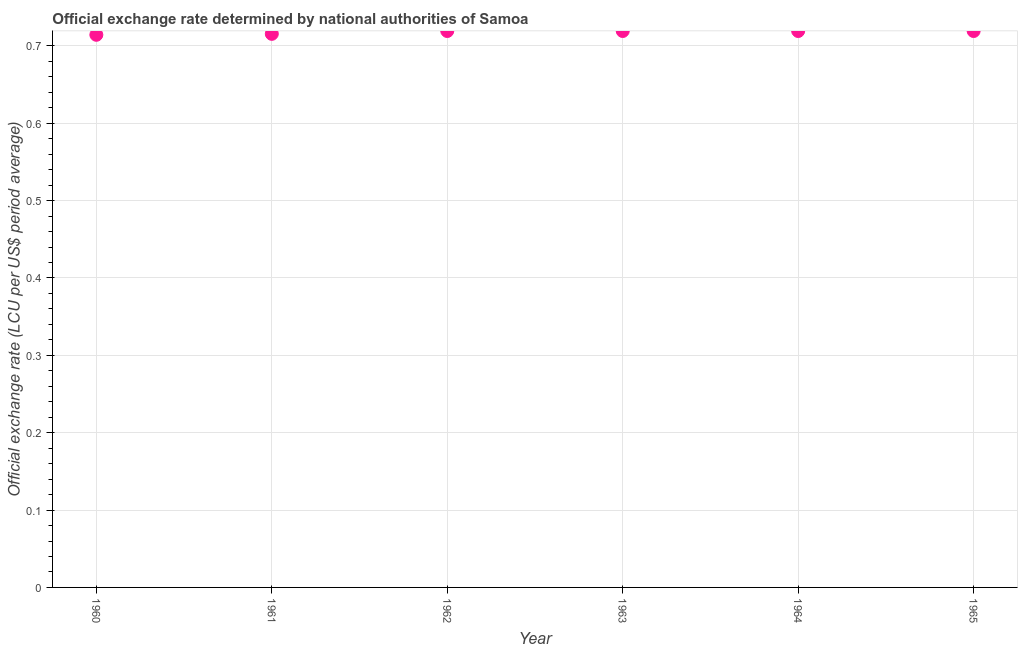What is the official exchange rate in 1965?
Make the answer very short. 0.72. Across all years, what is the maximum official exchange rate?
Make the answer very short. 0.72. Across all years, what is the minimum official exchange rate?
Your answer should be very brief. 0.71. In which year was the official exchange rate maximum?
Provide a succinct answer. 1962. In which year was the official exchange rate minimum?
Provide a short and direct response. 1960. What is the sum of the official exchange rate?
Provide a succinct answer. 4.31. What is the difference between the official exchange rate in 1961 and 1965?
Give a very brief answer. -0. What is the average official exchange rate per year?
Offer a terse response. 0.72. What is the median official exchange rate?
Provide a short and direct response. 0.72. Do a majority of the years between 1964 and 1960 (inclusive) have official exchange rate greater than 0.36000000000000004 ?
Ensure brevity in your answer.  Yes. What is the ratio of the official exchange rate in 1961 to that in 1962?
Ensure brevity in your answer.  0.99. Is the official exchange rate in 1962 less than that in 1964?
Make the answer very short. No. Is the difference between the official exchange rate in 1963 and 1964 greater than the difference between any two years?
Give a very brief answer. No. What is the difference between the highest and the second highest official exchange rate?
Provide a short and direct response. 0. Is the sum of the official exchange rate in 1963 and 1965 greater than the maximum official exchange rate across all years?
Offer a very short reply. Yes. What is the difference between the highest and the lowest official exchange rate?
Make the answer very short. 0. Does the official exchange rate monotonically increase over the years?
Your response must be concise. No. How many dotlines are there?
Offer a very short reply. 1. How many years are there in the graph?
Your answer should be very brief. 6. Are the values on the major ticks of Y-axis written in scientific E-notation?
Your answer should be very brief. No. Does the graph contain grids?
Make the answer very short. Yes. What is the title of the graph?
Ensure brevity in your answer.  Official exchange rate determined by national authorities of Samoa. What is the label or title of the Y-axis?
Provide a short and direct response. Official exchange rate (LCU per US$ period average). What is the Official exchange rate (LCU per US$ period average) in 1960?
Offer a very short reply. 0.71. What is the Official exchange rate (LCU per US$ period average) in 1961?
Keep it short and to the point. 0.72. What is the Official exchange rate (LCU per US$ period average) in 1962?
Offer a very short reply. 0.72. What is the Official exchange rate (LCU per US$ period average) in 1963?
Your response must be concise. 0.72. What is the Official exchange rate (LCU per US$ period average) in 1964?
Your answer should be compact. 0.72. What is the Official exchange rate (LCU per US$ period average) in 1965?
Provide a succinct answer. 0.72. What is the difference between the Official exchange rate (LCU per US$ period average) in 1960 and 1961?
Your answer should be very brief. -0. What is the difference between the Official exchange rate (LCU per US$ period average) in 1960 and 1962?
Your answer should be compact. -0. What is the difference between the Official exchange rate (LCU per US$ period average) in 1960 and 1963?
Provide a succinct answer. -0. What is the difference between the Official exchange rate (LCU per US$ period average) in 1960 and 1964?
Offer a terse response. -0. What is the difference between the Official exchange rate (LCU per US$ period average) in 1960 and 1965?
Offer a terse response. -0. What is the difference between the Official exchange rate (LCU per US$ period average) in 1961 and 1962?
Your response must be concise. -0. What is the difference between the Official exchange rate (LCU per US$ period average) in 1961 and 1963?
Your answer should be very brief. -0. What is the difference between the Official exchange rate (LCU per US$ period average) in 1961 and 1964?
Give a very brief answer. -0. What is the difference between the Official exchange rate (LCU per US$ period average) in 1961 and 1965?
Offer a very short reply. -0. What is the difference between the Official exchange rate (LCU per US$ period average) in 1962 and 1963?
Provide a short and direct response. 0. What is the difference between the Official exchange rate (LCU per US$ period average) in 1962 and 1965?
Keep it short and to the point. 0. What is the difference between the Official exchange rate (LCU per US$ period average) in 1963 and 1964?
Offer a terse response. 0. What is the difference between the Official exchange rate (LCU per US$ period average) in 1963 and 1965?
Provide a succinct answer. 0. What is the difference between the Official exchange rate (LCU per US$ period average) in 1964 and 1965?
Your answer should be very brief. 0. What is the ratio of the Official exchange rate (LCU per US$ period average) in 1960 to that in 1962?
Offer a terse response. 0.99. What is the ratio of the Official exchange rate (LCU per US$ period average) in 1960 to that in 1965?
Make the answer very short. 0.99. What is the ratio of the Official exchange rate (LCU per US$ period average) in 1961 to that in 1965?
Your response must be concise. 0.99. What is the ratio of the Official exchange rate (LCU per US$ period average) in 1962 to that in 1965?
Give a very brief answer. 1. What is the ratio of the Official exchange rate (LCU per US$ period average) in 1963 to that in 1964?
Ensure brevity in your answer.  1. What is the ratio of the Official exchange rate (LCU per US$ period average) in 1963 to that in 1965?
Give a very brief answer. 1. What is the ratio of the Official exchange rate (LCU per US$ period average) in 1964 to that in 1965?
Offer a very short reply. 1. 